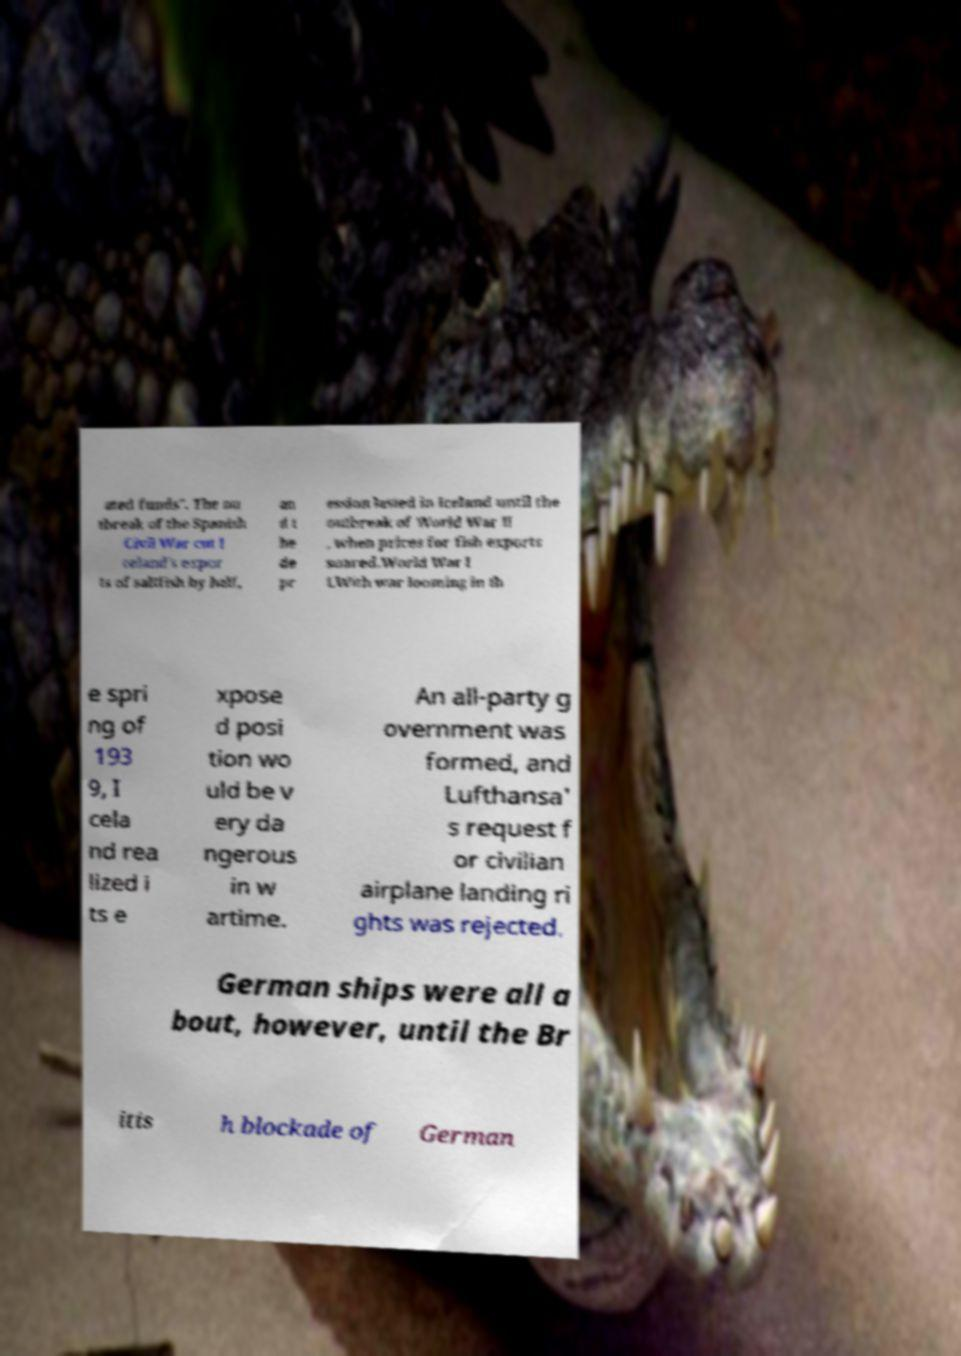Please read and relay the text visible in this image. What does it say? ated funds". The ou tbreak of the Spanish Civil War cut I celand's expor ts of saltfish by half, an d t he de pr ession lasted in Iceland until the outbreak of World War II , when prices for fish exports soared.World War I I.With war looming in th e spri ng of 193 9, I cela nd rea lized i ts e xpose d posi tion wo uld be v ery da ngerous in w artime. An all-party g overnment was formed, and Lufthansa' s request f or civilian airplane landing ri ghts was rejected. German ships were all a bout, however, until the Br itis h blockade of German 